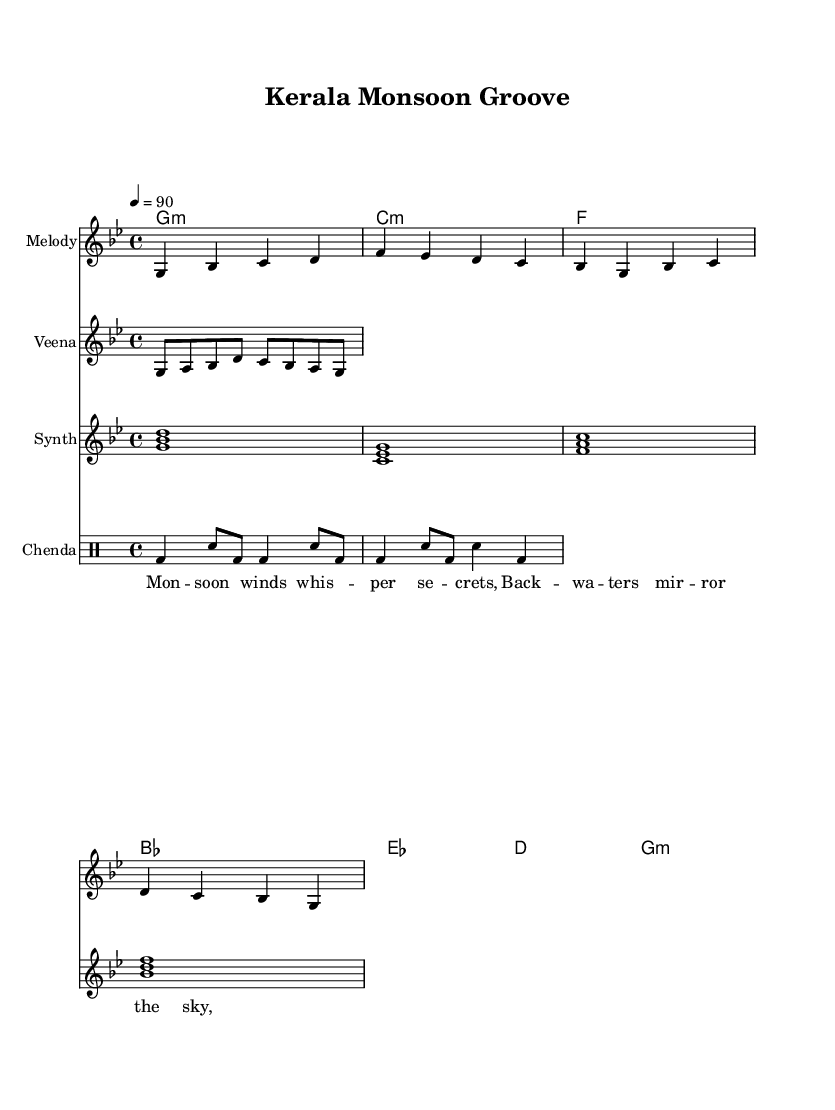What is the key signature of this music? The key signature indicated is G minor, which has two flats. This can be confirmed by looking at the beginning of the score where the key signature is displayed.
Answer: G minor What is the time signature of this music? The time signature is 4/4, which is indicated at the beginning of the music. This means there are four beats per measure, and the quarter note gets one beat.
Answer: 4/4 What is the tempo marking in this piece? The tempo marking is indicated as "4 = 90," meaning there are 90 quarter note beats per minute. This shows how fast the piece should be played.
Answer: 90 How many measures are in the melody? The melody is written in 8 measures, as counted from the beginning of the score to the end of the melody notes section. Each measure is separated by a bar line.
Answer: 8 What instrument plays the melody? The melody is played by the instrument labeled "Melody" in the staff notation. This denotes the primary melodic line of the piece.
Answer: Melody What type of traditional instrument is incorporated in this music? The traditional instrument included is the veena, which is explicitly mentioned in the staff notation. This adds a unique cultural element to the contemporary rhythm and blues fusion.
Answer: Veena What is the main rhythmic pattern of the drum? The main rhythmic pattern for the drum is specified in the drum staff as a combination of bass drum and snare hits in a specific sequence, characteristic of rhythmic patterns in R&B music.
Answer: Bass drum and snare 